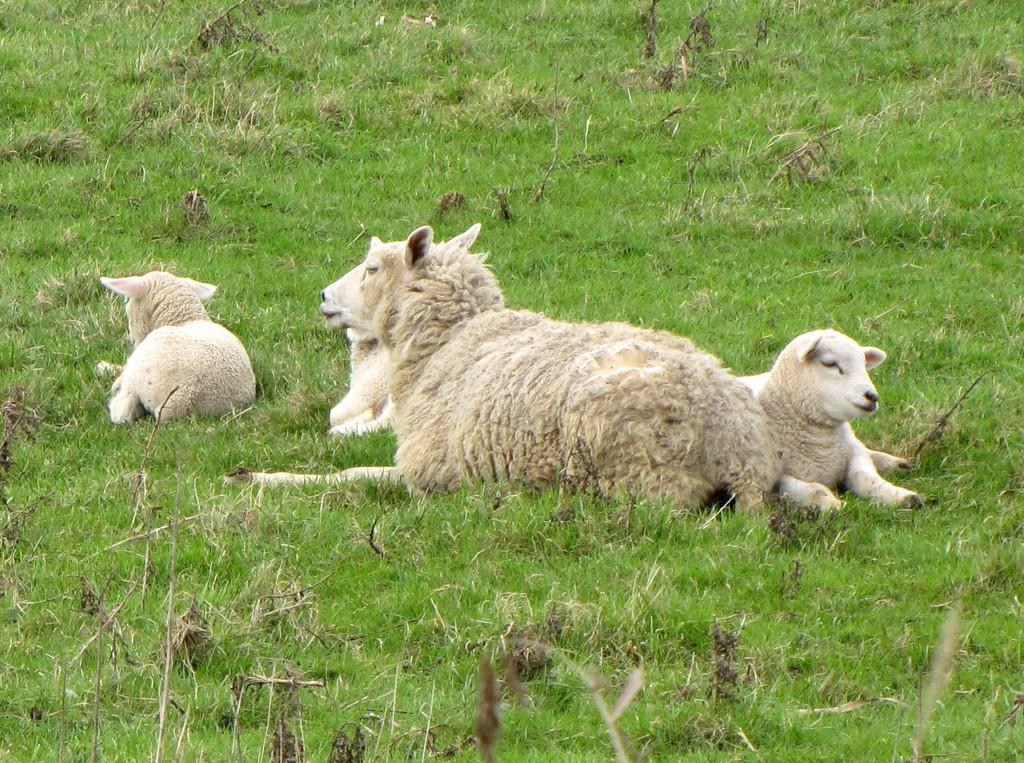Could you give a brief overview of what you see in this image? In this image there are sheep present on the grass. 